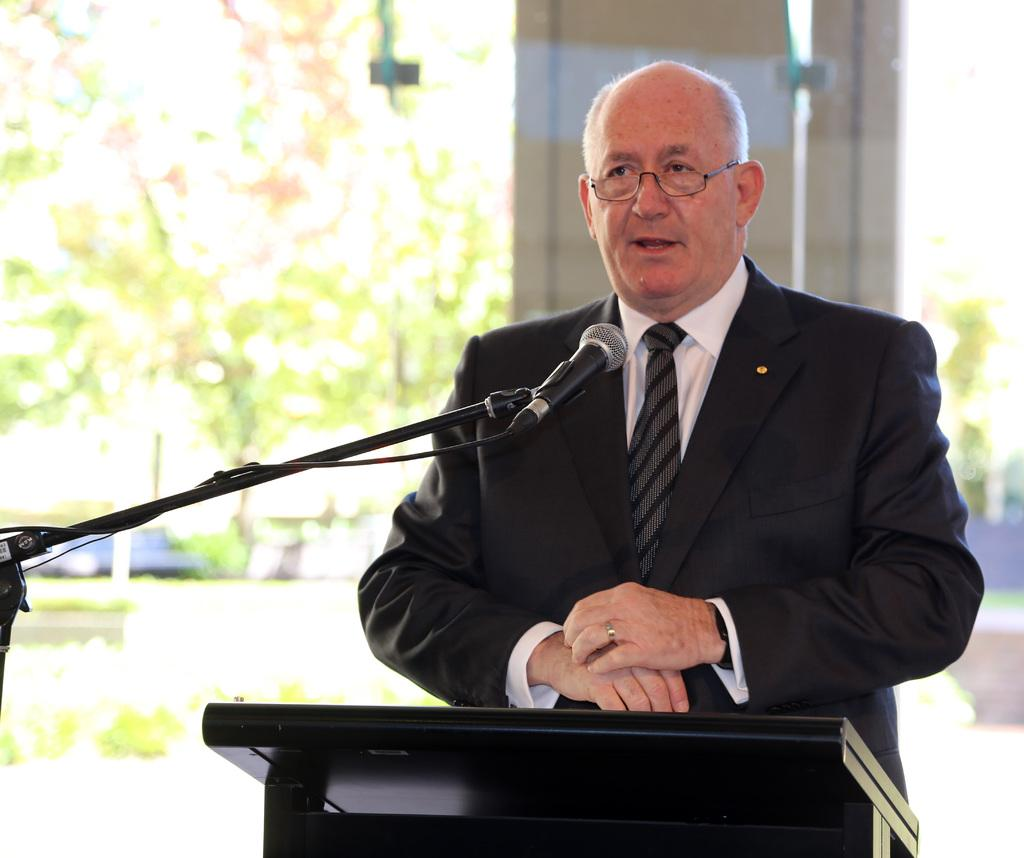What can be seen in the image? There is a person in the image. What is the person wearing? The person is wearing glasses (specs). What is the person doing in the image? The person is standing and talking. What is in front of the person? There is a podium, a microphone, and a microphone stand in front of the person. How is the background of the image? The background of the image is blurred. What type of harmony is being played on the shelf in the image? There is no shelf or harmony present in the image. What degree does the person in the image have? The provided facts do not mention the person's degree, so it cannot be determined from the image. 